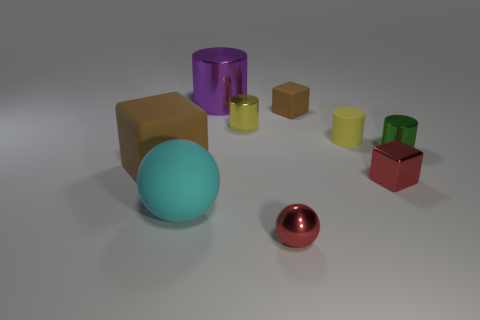Add 1 large brown cylinders. How many objects exist? 10 Subtract all spheres. How many objects are left? 7 Add 7 tiny red spheres. How many tiny red spheres exist? 8 Subtract 0 purple blocks. How many objects are left? 9 Subtract all brown things. Subtract all tiny red metal balls. How many objects are left? 6 Add 8 yellow things. How many yellow things are left? 10 